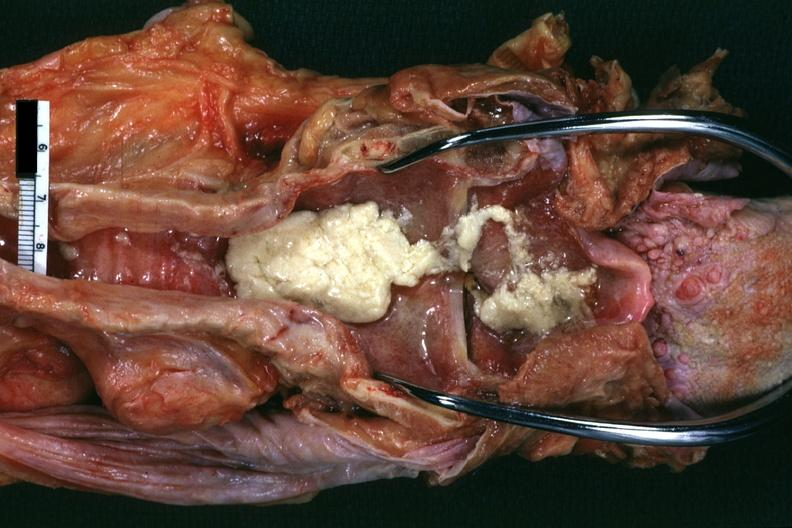what is present?
Answer the question using a single word or phrase. Aspiration 